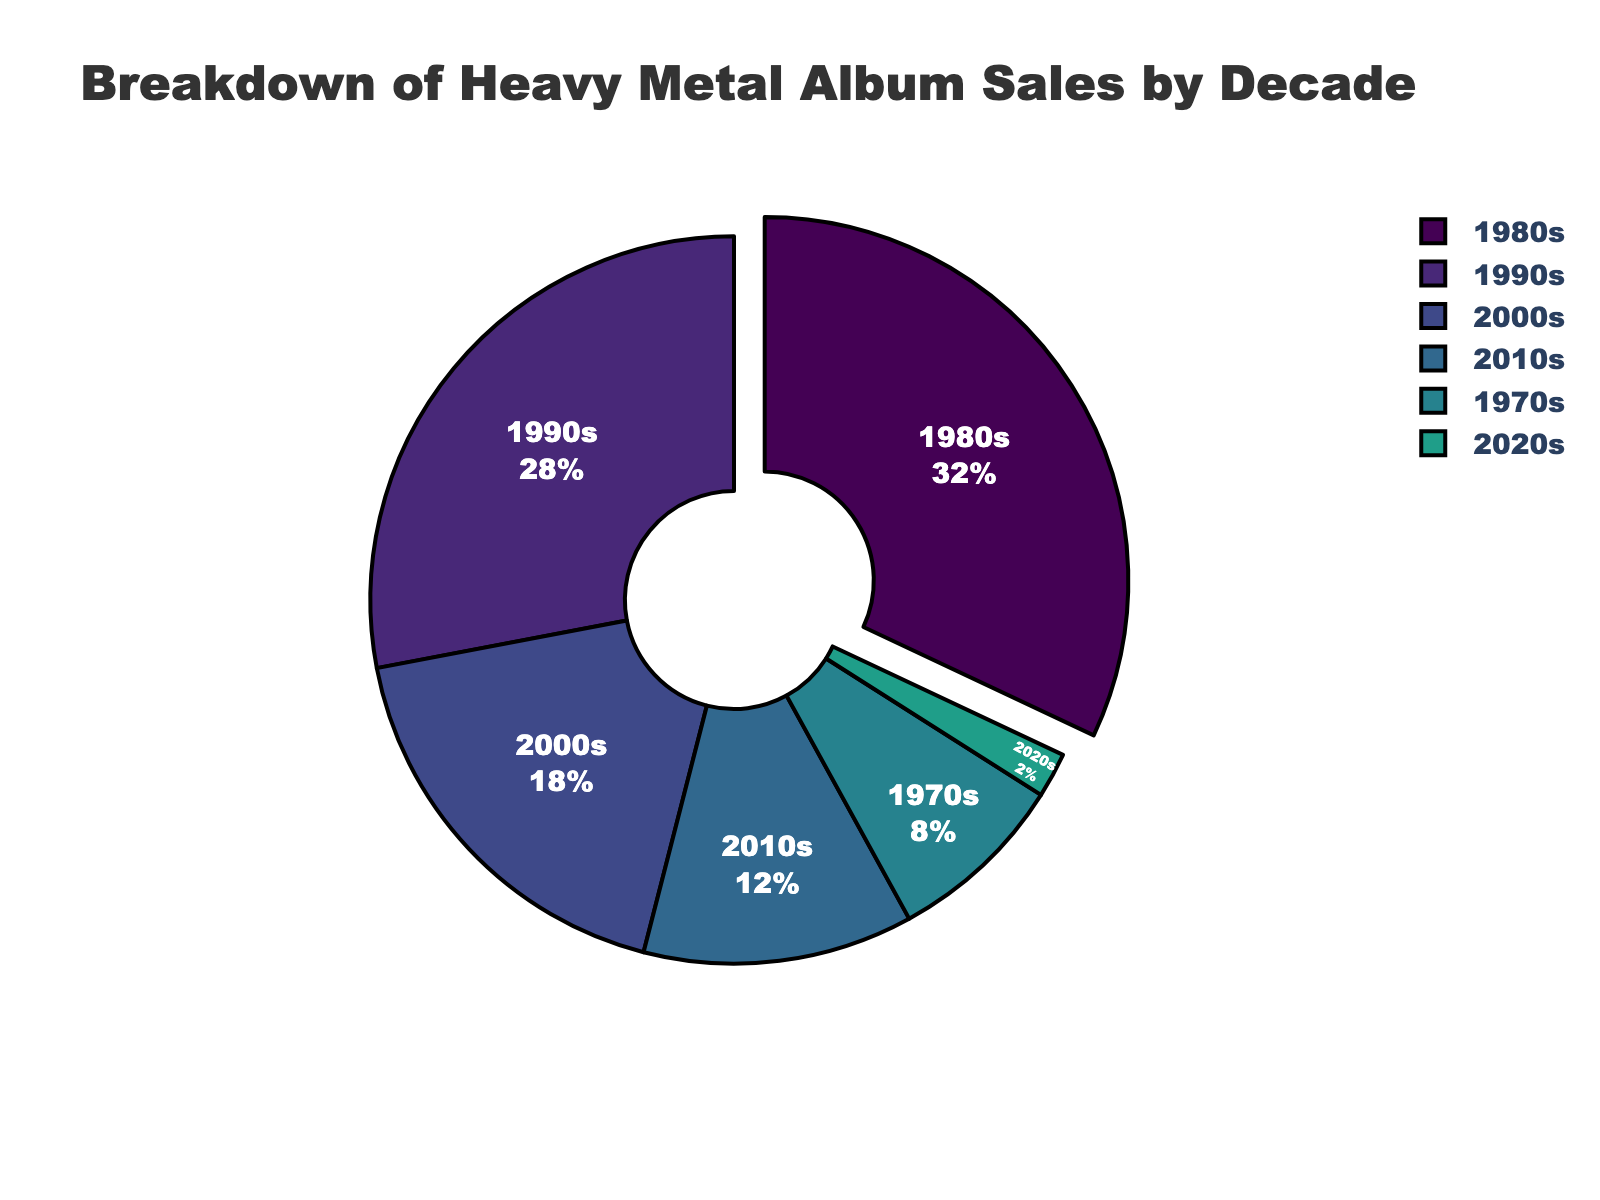What percentage of heavy metal album sales were in the 1980s? The 1980s section of the pie chart indicates the percentage of heavy metal album sales during that decade. By referring to the figure, it shows 32%.
Answer: 32% Which decade had the lowest percentage of heavy metal album sales? By examining the slices of the pie chart, the smallest section represents the 2020s. The label indicates 2%, which is the lowest.
Answer: 2020s How much more significant was the 1980s in heavy metal album sales compared to the 2010s? The pie chart indicates 32% for the 1980s and 12% for the 2010s. Calculating the difference, 32% - 12% = 20%.
Answer: 20% What is the total percentage of heavy metal album sales for the 1990s and 2000s combined? Combining the percentages from the 1990s and 2000s, we add 28% (1990s) and 18% (2000s). The total is 28% + 18% = 46%.
Answer: 46% Which decade is clearly visually emphasized in the pie chart and why? The 1980s section is visually separated by being pulled out slightly from the pie chart. This indicates its significance with the highest percentage.
Answer: 1980s How do the heavy metal album sales of the 2000s compare to those of the 1970s? The chart shows 18% for the 2000s and 8% for the 1970s. Comparatively, the 2000s have a higher percentage by 10%.
Answer: The 2000s are higher by 10% How many decades have a higher percentage of heavy metal album sales than the 2000s? Observing the chart, the decades with higher percentages than the 2000s (18%) are the 1980s (32%) and 1990s (28%). So, there are two such decades.
Answer: 2 What fraction of the total heavy metal album sales is contributed by the 1970s and the 2020s together? The 1970s contribute 8% and the 2020s contribute 2%. Combined, they account for 8% + 2% = 10%. As a fraction, this is 10/100 or 1/10.
Answer: 1/10 What is the difference in heavy metal album sales percentages between the 2000s and the 2010s? The pie chart shows 18% for the 2000s and 12% for the 2010s. By subtracting the 2010s' percentage from the 2000s', we get 18% - 12% = 6%.
Answer: 6% 